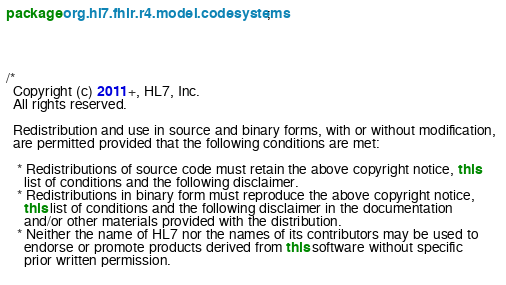Convert code to text. <code><loc_0><loc_0><loc_500><loc_500><_Java_>package org.hl7.fhir.r4.model.codesystems;




/*
  Copyright (c) 2011+, HL7, Inc.
  All rights reserved.
  
  Redistribution and use in source and binary forms, with or without modification, 
  are permitted provided that the following conditions are met:
  
   * Redistributions of source code must retain the above copyright notice, this 
     list of conditions and the following disclaimer.
   * Redistributions in binary form must reproduce the above copyright notice, 
     this list of conditions and the following disclaimer in the documentation 
     and/or other materials provided with the distribution.
   * Neither the name of HL7 nor the names of its contributors may be used to 
     endorse or promote products derived from this software without specific 
     prior written permission.
  </code> 